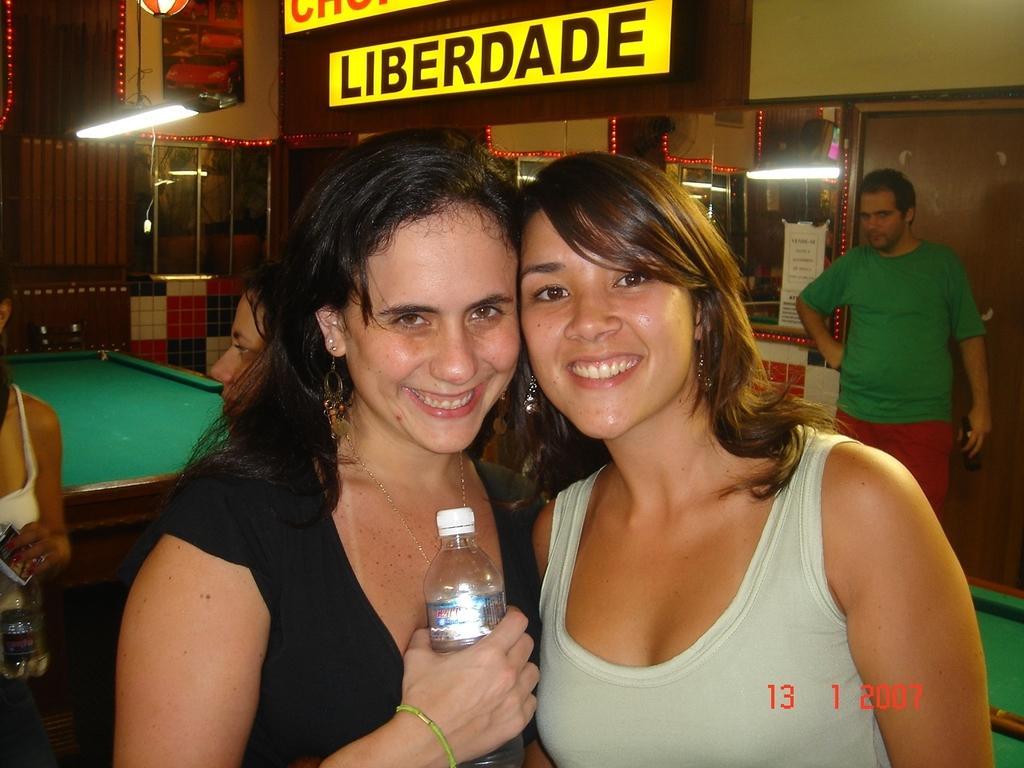In one or two sentences, can you explain what this image depicts? In this image I can see two women are smiling among them this woman is holding a bottle in the hand. In the background I can see people, lights, a wall, a door and snooker tables. 